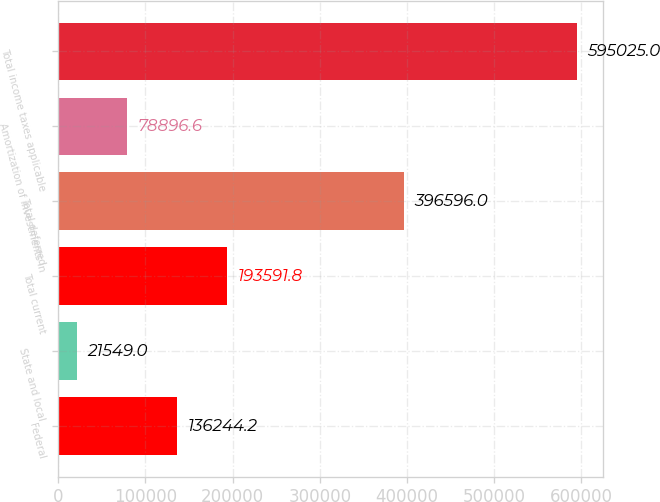<chart> <loc_0><loc_0><loc_500><loc_500><bar_chart><fcel>Federal<fcel>State and local<fcel>Total current<fcel>Total deferred<fcel>Amortization of investments in<fcel>Total income taxes applicable<nl><fcel>136244<fcel>21549<fcel>193592<fcel>396596<fcel>78896.6<fcel>595025<nl></chart> 